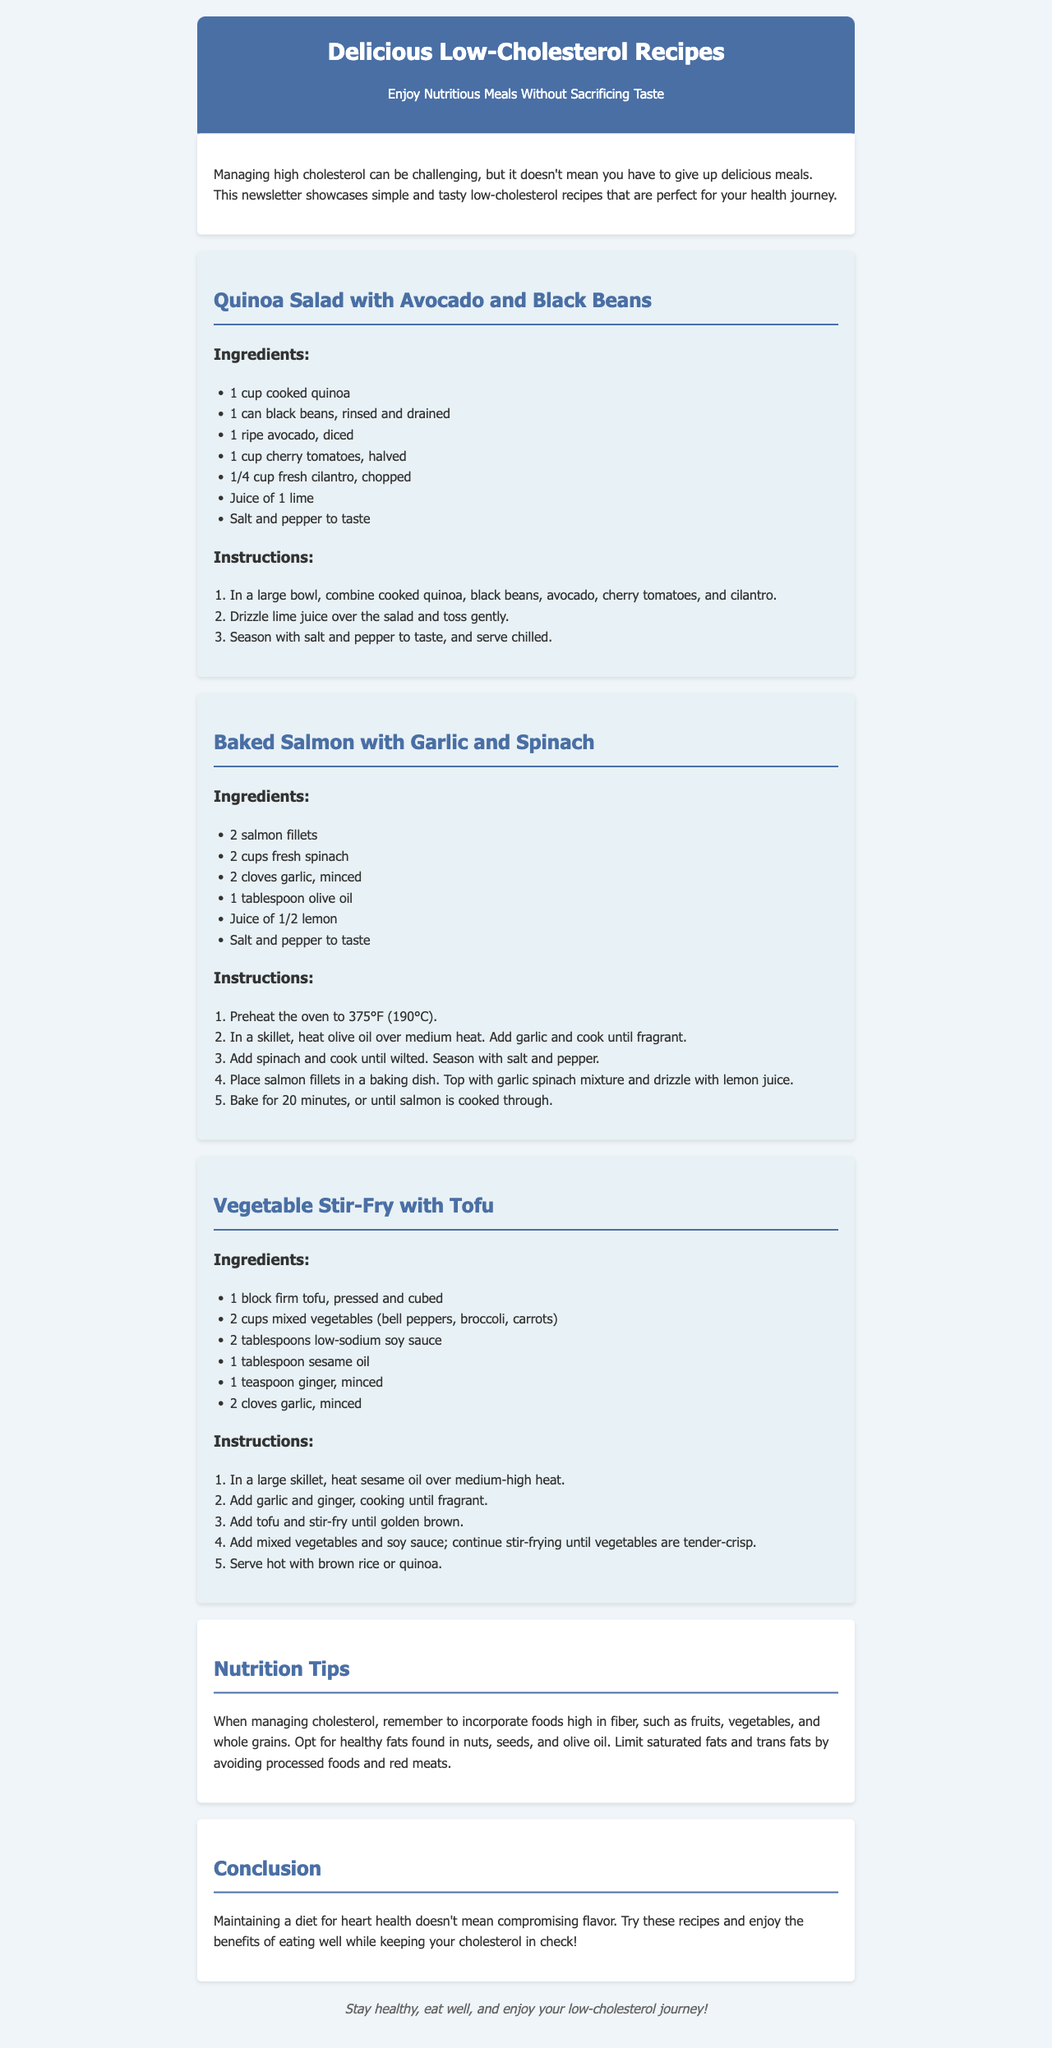What is the title of the newsletter? The title is prominently displayed at the top of the document.
Answer: Delicious Low-Cholesterol Recipes How many recipes are included in the newsletter? Each recipe is presented within its own section, and there are three in total.
Answer: 3 What is the key ingredient in the Quinoa Salad? The main ingredients are listed, and 'quinoa' is specifically highlighted as the first item.
Answer: Quinoa What type of oil is used in the Baked Salmon recipe? The ingredients list includes 'olive oil.'
Answer: Olive oil What is mentioned as a good practice when managing cholesterol? The Nutrition Tips section provides guidance, and fiber-rich foods are specifically noted.
Answer: Foods high in fiber Which recipe includes tofu? The recipe list shows three different dishes, and only one mentions tofu specifically.
Answer: Vegetable Stir-Fry with Tofu What should you limit in your diet according to the nutrition tips? The advice given in the Nutrition Tips highlights both saturated and trans fats.
Answer: Saturated fats and trans fats What is the suggested cooking temperature for the Baked Salmon? The instructions clearly state the required oven temperature for baking.
Answer: 375°F (190°C) What is a key component of the conclusion? The conclusion summarizes the document's main ethos about heart health.
Answer: Enjoy the benefits of eating well 